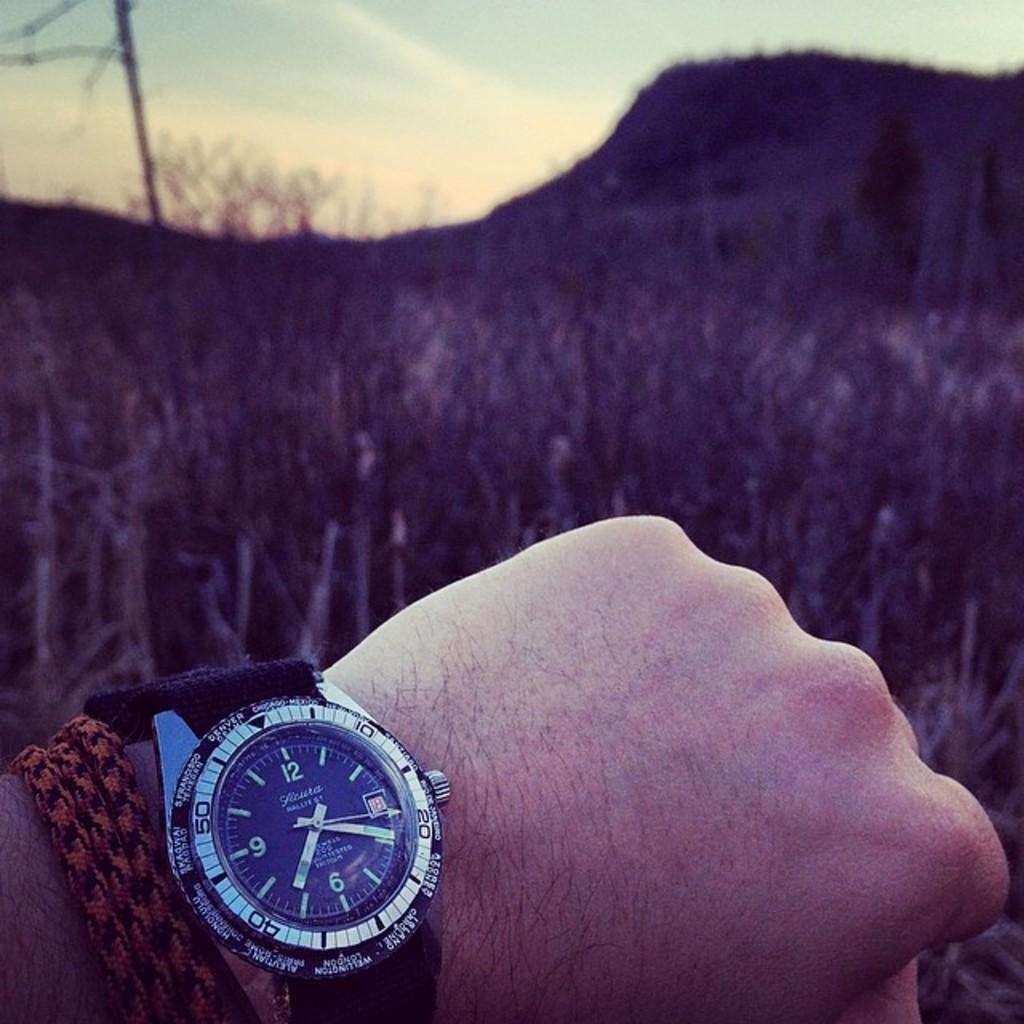What time is displayed on the watch?
Keep it short and to the point. 7:20. 